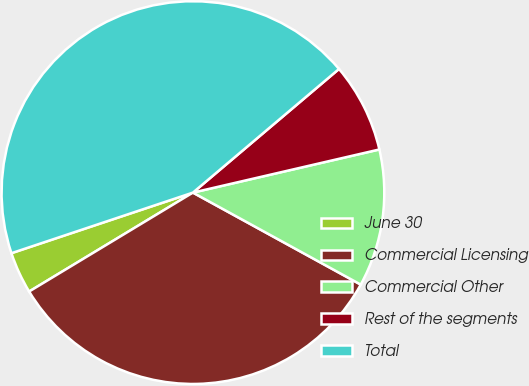<chart> <loc_0><loc_0><loc_500><loc_500><pie_chart><fcel>June 30<fcel>Commercial Licensing<fcel>Commercial Other<fcel>Rest of the segments<fcel>Total<nl><fcel>3.52%<fcel>33.37%<fcel>11.6%<fcel>7.56%<fcel>43.95%<nl></chart> 